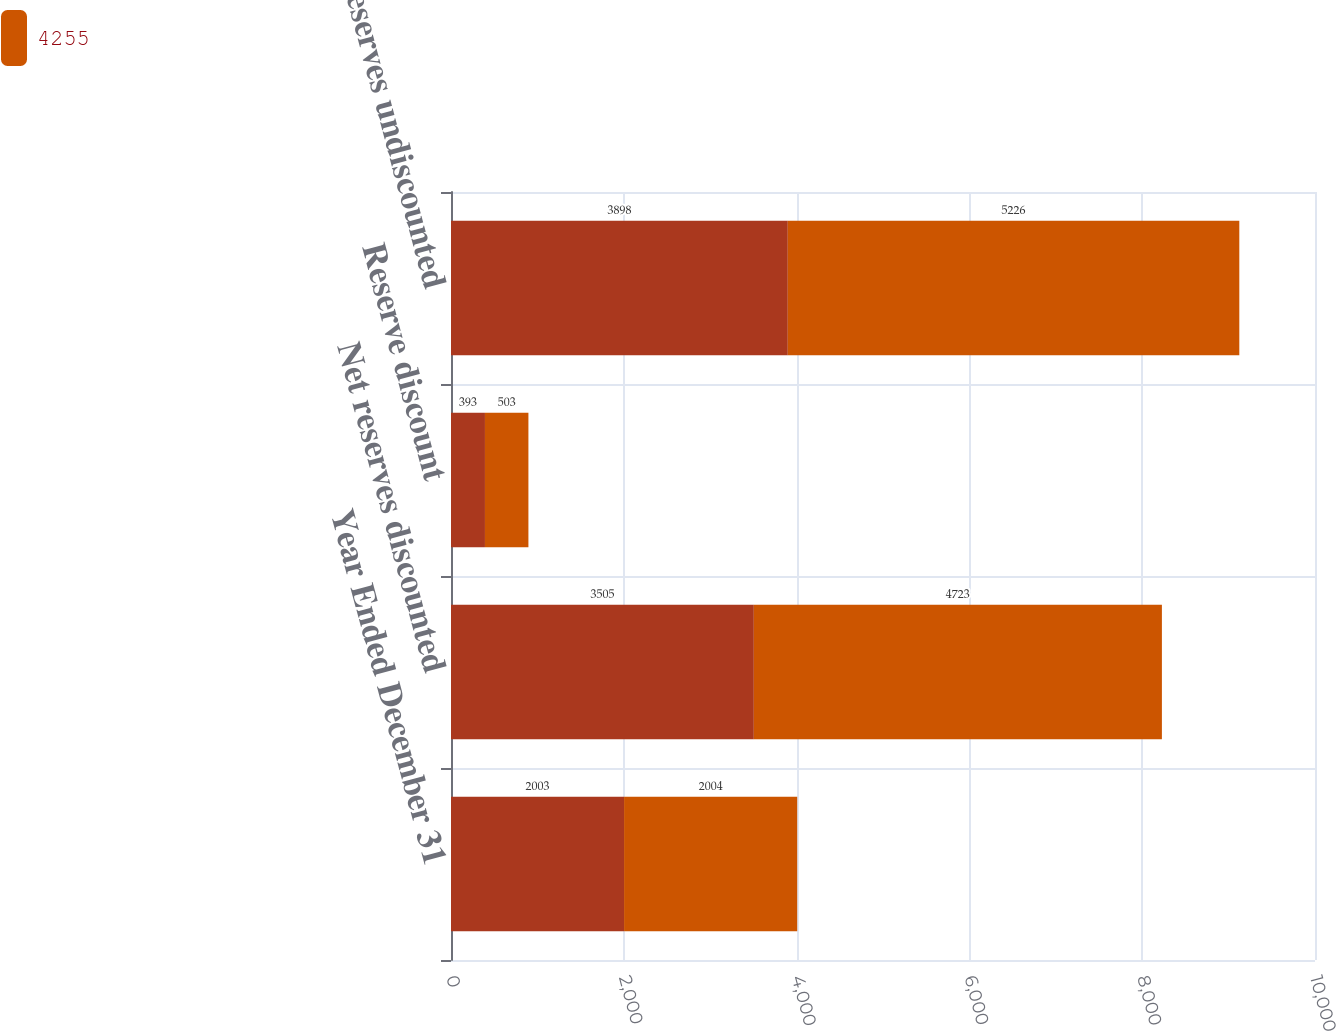<chart> <loc_0><loc_0><loc_500><loc_500><stacked_bar_chart><ecel><fcel>Year Ended December 31<fcel>Net reserves discounted<fcel>Reserve discount<fcel>Net reserves undiscounted<nl><fcel>nan<fcel>2003<fcel>3505<fcel>393<fcel>3898<nl><fcel>4255<fcel>2004<fcel>4723<fcel>503<fcel>5226<nl></chart> 